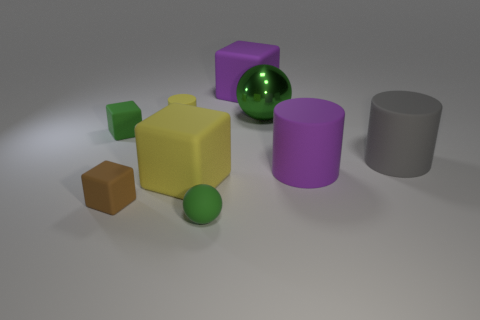Subtract all spheres. How many objects are left? 7 Add 9 tiny green spheres. How many tiny green spheres exist? 10 Subtract 0 purple balls. How many objects are left? 9 Subtract all blocks. Subtract all cyan shiny spheres. How many objects are left? 5 Add 2 big yellow matte cubes. How many big yellow matte cubes are left? 3 